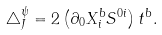Convert formula to latex. <formula><loc_0><loc_0><loc_500><loc_500>\triangle _ { J } ^ { \psi } = 2 \left ( \partial _ { 0 } X _ { i } ^ { b } S ^ { 0 i } \right ) t ^ { b } .</formula> 